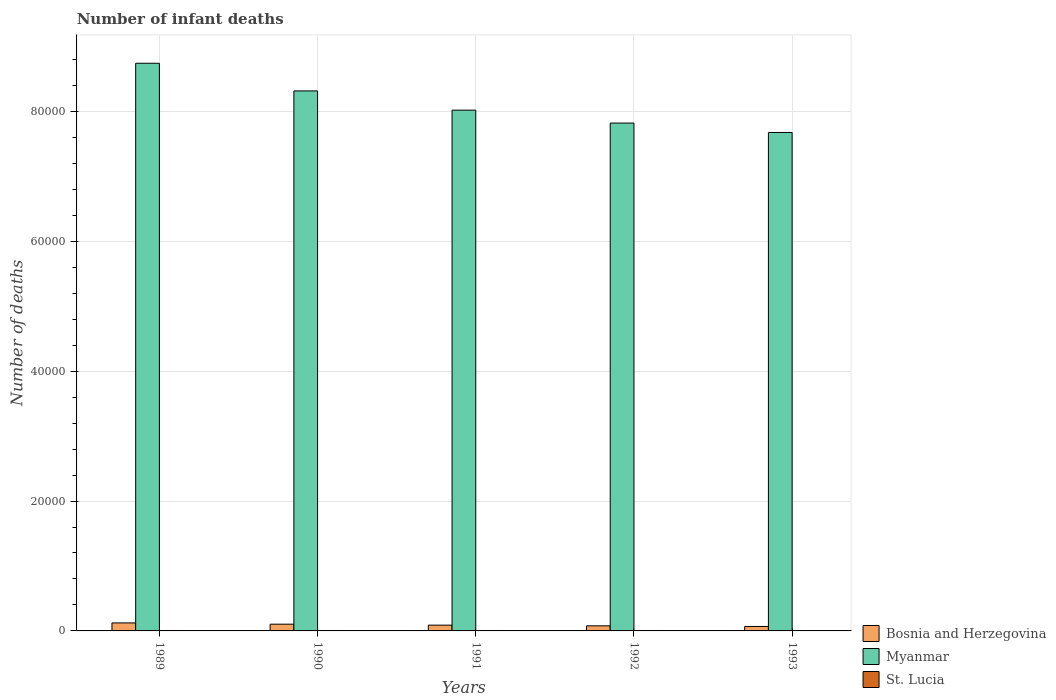How many groups of bars are there?
Offer a very short reply. 5. Are the number of bars per tick equal to the number of legend labels?
Make the answer very short. Yes. What is the label of the 5th group of bars from the left?
Provide a succinct answer. 1993. In how many cases, is the number of bars for a given year not equal to the number of legend labels?
Offer a very short reply. 0. What is the number of infant deaths in Myanmar in 1993?
Ensure brevity in your answer.  7.67e+04. Across all years, what is the maximum number of infant deaths in St. Lucia?
Provide a short and direct response. 67. Across all years, what is the minimum number of infant deaths in Bosnia and Herzegovina?
Offer a terse response. 687. In which year was the number of infant deaths in St. Lucia maximum?
Ensure brevity in your answer.  1989. What is the total number of infant deaths in Myanmar in the graph?
Make the answer very short. 4.06e+05. What is the difference between the number of infant deaths in Bosnia and Herzegovina in 1989 and that in 1993?
Your answer should be very brief. 547. What is the difference between the number of infant deaths in Myanmar in 1993 and the number of infant deaths in Bosnia and Herzegovina in 1990?
Keep it short and to the point. 7.57e+04. What is the average number of infant deaths in Myanmar per year?
Offer a very short reply. 8.11e+04. In the year 1993, what is the difference between the number of infant deaths in Bosnia and Herzegovina and number of infant deaths in Myanmar?
Your answer should be compact. -7.61e+04. What is the ratio of the number of infant deaths in Myanmar in 1989 to that in 1990?
Offer a very short reply. 1.05. Is the number of infant deaths in Myanmar in 1989 less than that in 1993?
Ensure brevity in your answer.  No. What is the difference between the highest and the lowest number of infant deaths in Bosnia and Herzegovina?
Make the answer very short. 547. In how many years, is the number of infant deaths in St. Lucia greater than the average number of infant deaths in St. Lucia taken over all years?
Provide a short and direct response. 3. What does the 3rd bar from the left in 1993 represents?
Your response must be concise. St. Lucia. What does the 3rd bar from the right in 1993 represents?
Provide a succinct answer. Bosnia and Herzegovina. Is it the case that in every year, the sum of the number of infant deaths in Myanmar and number of infant deaths in St. Lucia is greater than the number of infant deaths in Bosnia and Herzegovina?
Provide a succinct answer. Yes. Are all the bars in the graph horizontal?
Ensure brevity in your answer.  No. Are the values on the major ticks of Y-axis written in scientific E-notation?
Keep it short and to the point. No. Does the graph contain grids?
Your answer should be very brief. Yes. Where does the legend appear in the graph?
Provide a succinct answer. Bottom right. How are the legend labels stacked?
Provide a succinct answer. Vertical. What is the title of the graph?
Give a very brief answer. Number of infant deaths. What is the label or title of the X-axis?
Give a very brief answer. Years. What is the label or title of the Y-axis?
Offer a terse response. Number of deaths. What is the Number of deaths of Bosnia and Herzegovina in 1989?
Make the answer very short. 1234. What is the Number of deaths of Myanmar in 1989?
Offer a terse response. 8.74e+04. What is the Number of deaths in Bosnia and Herzegovina in 1990?
Provide a short and direct response. 1037. What is the Number of deaths in Myanmar in 1990?
Make the answer very short. 8.31e+04. What is the Number of deaths of Bosnia and Herzegovina in 1991?
Ensure brevity in your answer.  888. What is the Number of deaths in Myanmar in 1991?
Make the answer very short. 8.02e+04. What is the Number of deaths of St. Lucia in 1991?
Your answer should be very brief. 66. What is the Number of deaths of Bosnia and Herzegovina in 1992?
Your answer should be compact. 784. What is the Number of deaths in Myanmar in 1992?
Provide a short and direct response. 7.82e+04. What is the Number of deaths in Bosnia and Herzegovina in 1993?
Your response must be concise. 687. What is the Number of deaths of Myanmar in 1993?
Offer a terse response. 7.67e+04. Across all years, what is the maximum Number of deaths in Bosnia and Herzegovina?
Make the answer very short. 1234. Across all years, what is the maximum Number of deaths in Myanmar?
Offer a terse response. 8.74e+04. Across all years, what is the minimum Number of deaths of Bosnia and Herzegovina?
Make the answer very short. 687. Across all years, what is the minimum Number of deaths of Myanmar?
Provide a short and direct response. 7.67e+04. What is the total Number of deaths of Bosnia and Herzegovina in the graph?
Your answer should be compact. 4630. What is the total Number of deaths in Myanmar in the graph?
Provide a short and direct response. 4.06e+05. What is the total Number of deaths of St. Lucia in the graph?
Ensure brevity in your answer.  328. What is the difference between the Number of deaths of Bosnia and Herzegovina in 1989 and that in 1990?
Your answer should be compact. 197. What is the difference between the Number of deaths of Myanmar in 1989 and that in 1990?
Give a very brief answer. 4257. What is the difference between the Number of deaths of St. Lucia in 1989 and that in 1990?
Make the answer very short. 1. What is the difference between the Number of deaths in Bosnia and Herzegovina in 1989 and that in 1991?
Make the answer very short. 346. What is the difference between the Number of deaths of Myanmar in 1989 and that in 1991?
Make the answer very short. 7220. What is the difference between the Number of deaths in Bosnia and Herzegovina in 1989 and that in 1992?
Offer a terse response. 450. What is the difference between the Number of deaths of Myanmar in 1989 and that in 1992?
Give a very brief answer. 9208. What is the difference between the Number of deaths of Bosnia and Herzegovina in 1989 and that in 1993?
Make the answer very short. 547. What is the difference between the Number of deaths in Myanmar in 1989 and that in 1993?
Your answer should be very brief. 1.07e+04. What is the difference between the Number of deaths of Bosnia and Herzegovina in 1990 and that in 1991?
Offer a terse response. 149. What is the difference between the Number of deaths in Myanmar in 1990 and that in 1991?
Provide a short and direct response. 2963. What is the difference between the Number of deaths of Bosnia and Herzegovina in 1990 and that in 1992?
Your answer should be compact. 253. What is the difference between the Number of deaths in Myanmar in 1990 and that in 1992?
Your answer should be very brief. 4951. What is the difference between the Number of deaths in St. Lucia in 1990 and that in 1992?
Your answer should be very brief. 1. What is the difference between the Number of deaths of Bosnia and Herzegovina in 1990 and that in 1993?
Provide a short and direct response. 350. What is the difference between the Number of deaths in Myanmar in 1990 and that in 1993?
Ensure brevity in your answer.  6398. What is the difference between the Number of deaths in Bosnia and Herzegovina in 1991 and that in 1992?
Keep it short and to the point. 104. What is the difference between the Number of deaths in Myanmar in 1991 and that in 1992?
Your response must be concise. 1988. What is the difference between the Number of deaths in St. Lucia in 1991 and that in 1992?
Offer a terse response. 1. What is the difference between the Number of deaths of Bosnia and Herzegovina in 1991 and that in 1993?
Keep it short and to the point. 201. What is the difference between the Number of deaths in Myanmar in 1991 and that in 1993?
Your answer should be compact. 3435. What is the difference between the Number of deaths in St. Lucia in 1991 and that in 1993?
Offer a very short reply. 2. What is the difference between the Number of deaths in Bosnia and Herzegovina in 1992 and that in 1993?
Your answer should be compact. 97. What is the difference between the Number of deaths in Myanmar in 1992 and that in 1993?
Keep it short and to the point. 1447. What is the difference between the Number of deaths of Bosnia and Herzegovina in 1989 and the Number of deaths of Myanmar in 1990?
Offer a very short reply. -8.19e+04. What is the difference between the Number of deaths of Bosnia and Herzegovina in 1989 and the Number of deaths of St. Lucia in 1990?
Ensure brevity in your answer.  1168. What is the difference between the Number of deaths in Myanmar in 1989 and the Number of deaths in St. Lucia in 1990?
Your response must be concise. 8.73e+04. What is the difference between the Number of deaths in Bosnia and Herzegovina in 1989 and the Number of deaths in Myanmar in 1991?
Give a very brief answer. -7.89e+04. What is the difference between the Number of deaths in Bosnia and Herzegovina in 1989 and the Number of deaths in St. Lucia in 1991?
Offer a terse response. 1168. What is the difference between the Number of deaths in Myanmar in 1989 and the Number of deaths in St. Lucia in 1991?
Offer a terse response. 8.73e+04. What is the difference between the Number of deaths of Bosnia and Herzegovina in 1989 and the Number of deaths of Myanmar in 1992?
Offer a terse response. -7.70e+04. What is the difference between the Number of deaths in Bosnia and Herzegovina in 1989 and the Number of deaths in St. Lucia in 1992?
Your answer should be compact. 1169. What is the difference between the Number of deaths in Myanmar in 1989 and the Number of deaths in St. Lucia in 1992?
Provide a short and direct response. 8.73e+04. What is the difference between the Number of deaths of Bosnia and Herzegovina in 1989 and the Number of deaths of Myanmar in 1993?
Your answer should be very brief. -7.55e+04. What is the difference between the Number of deaths of Bosnia and Herzegovina in 1989 and the Number of deaths of St. Lucia in 1993?
Offer a very short reply. 1170. What is the difference between the Number of deaths in Myanmar in 1989 and the Number of deaths in St. Lucia in 1993?
Offer a very short reply. 8.73e+04. What is the difference between the Number of deaths in Bosnia and Herzegovina in 1990 and the Number of deaths in Myanmar in 1991?
Offer a very short reply. -7.91e+04. What is the difference between the Number of deaths in Bosnia and Herzegovina in 1990 and the Number of deaths in St. Lucia in 1991?
Give a very brief answer. 971. What is the difference between the Number of deaths in Myanmar in 1990 and the Number of deaths in St. Lucia in 1991?
Offer a terse response. 8.31e+04. What is the difference between the Number of deaths of Bosnia and Herzegovina in 1990 and the Number of deaths of Myanmar in 1992?
Offer a terse response. -7.72e+04. What is the difference between the Number of deaths of Bosnia and Herzegovina in 1990 and the Number of deaths of St. Lucia in 1992?
Give a very brief answer. 972. What is the difference between the Number of deaths of Myanmar in 1990 and the Number of deaths of St. Lucia in 1992?
Your answer should be compact. 8.31e+04. What is the difference between the Number of deaths of Bosnia and Herzegovina in 1990 and the Number of deaths of Myanmar in 1993?
Ensure brevity in your answer.  -7.57e+04. What is the difference between the Number of deaths of Bosnia and Herzegovina in 1990 and the Number of deaths of St. Lucia in 1993?
Keep it short and to the point. 973. What is the difference between the Number of deaths in Myanmar in 1990 and the Number of deaths in St. Lucia in 1993?
Keep it short and to the point. 8.31e+04. What is the difference between the Number of deaths of Bosnia and Herzegovina in 1991 and the Number of deaths of Myanmar in 1992?
Your answer should be very brief. -7.73e+04. What is the difference between the Number of deaths of Bosnia and Herzegovina in 1991 and the Number of deaths of St. Lucia in 1992?
Provide a short and direct response. 823. What is the difference between the Number of deaths of Myanmar in 1991 and the Number of deaths of St. Lucia in 1992?
Give a very brief answer. 8.01e+04. What is the difference between the Number of deaths of Bosnia and Herzegovina in 1991 and the Number of deaths of Myanmar in 1993?
Offer a terse response. -7.59e+04. What is the difference between the Number of deaths in Bosnia and Herzegovina in 1991 and the Number of deaths in St. Lucia in 1993?
Keep it short and to the point. 824. What is the difference between the Number of deaths of Myanmar in 1991 and the Number of deaths of St. Lucia in 1993?
Offer a very short reply. 8.01e+04. What is the difference between the Number of deaths of Bosnia and Herzegovina in 1992 and the Number of deaths of Myanmar in 1993?
Offer a terse response. -7.60e+04. What is the difference between the Number of deaths of Bosnia and Herzegovina in 1992 and the Number of deaths of St. Lucia in 1993?
Give a very brief answer. 720. What is the difference between the Number of deaths in Myanmar in 1992 and the Number of deaths in St. Lucia in 1993?
Make the answer very short. 7.81e+04. What is the average Number of deaths in Bosnia and Herzegovina per year?
Make the answer very short. 926. What is the average Number of deaths of Myanmar per year?
Ensure brevity in your answer.  8.11e+04. What is the average Number of deaths in St. Lucia per year?
Keep it short and to the point. 65.6. In the year 1989, what is the difference between the Number of deaths of Bosnia and Herzegovina and Number of deaths of Myanmar?
Make the answer very short. -8.62e+04. In the year 1989, what is the difference between the Number of deaths in Bosnia and Herzegovina and Number of deaths in St. Lucia?
Provide a succinct answer. 1167. In the year 1989, what is the difference between the Number of deaths of Myanmar and Number of deaths of St. Lucia?
Ensure brevity in your answer.  8.73e+04. In the year 1990, what is the difference between the Number of deaths in Bosnia and Herzegovina and Number of deaths in Myanmar?
Make the answer very short. -8.21e+04. In the year 1990, what is the difference between the Number of deaths of Bosnia and Herzegovina and Number of deaths of St. Lucia?
Give a very brief answer. 971. In the year 1990, what is the difference between the Number of deaths of Myanmar and Number of deaths of St. Lucia?
Offer a very short reply. 8.31e+04. In the year 1991, what is the difference between the Number of deaths in Bosnia and Herzegovina and Number of deaths in Myanmar?
Offer a terse response. -7.93e+04. In the year 1991, what is the difference between the Number of deaths of Bosnia and Herzegovina and Number of deaths of St. Lucia?
Offer a terse response. 822. In the year 1991, what is the difference between the Number of deaths of Myanmar and Number of deaths of St. Lucia?
Offer a very short reply. 8.01e+04. In the year 1992, what is the difference between the Number of deaths of Bosnia and Herzegovina and Number of deaths of Myanmar?
Provide a succinct answer. -7.74e+04. In the year 1992, what is the difference between the Number of deaths of Bosnia and Herzegovina and Number of deaths of St. Lucia?
Your answer should be compact. 719. In the year 1992, what is the difference between the Number of deaths of Myanmar and Number of deaths of St. Lucia?
Provide a short and direct response. 7.81e+04. In the year 1993, what is the difference between the Number of deaths of Bosnia and Herzegovina and Number of deaths of Myanmar?
Keep it short and to the point. -7.61e+04. In the year 1993, what is the difference between the Number of deaths in Bosnia and Herzegovina and Number of deaths in St. Lucia?
Make the answer very short. 623. In the year 1993, what is the difference between the Number of deaths in Myanmar and Number of deaths in St. Lucia?
Offer a very short reply. 7.67e+04. What is the ratio of the Number of deaths of Bosnia and Herzegovina in 1989 to that in 1990?
Provide a succinct answer. 1.19. What is the ratio of the Number of deaths of Myanmar in 1989 to that in 1990?
Your response must be concise. 1.05. What is the ratio of the Number of deaths of St. Lucia in 1989 to that in 1990?
Offer a terse response. 1.02. What is the ratio of the Number of deaths of Bosnia and Herzegovina in 1989 to that in 1991?
Keep it short and to the point. 1.39. What is the ratio of the Number of deaths of Myanmar in 1989 to that in 1991?
Offer a very short reply. 1.09. What is the ratio of the Number of deaths of St. Lucia in 1989 to that in 1991?
Make the answer very short. 1.02. What is the ratio of the Number of deaths of Bosnia and Herzegovina in 1989 to that in 1992?
Your response must be concise. 1.57. What is the ratio of the Number of deaths of Myanmar in 1989 to that in 1992?
Your response must be concise. 1.12. What is the ratio of the Number of deaths in St. Lucia in 1989 to that in 1992?
Your answer should be compact. 1.03. What is the ratio of the Number of deaths of Bosnia and Herzegovina in 1989 to that in 1993?
Your response must be concise. 1.8. What is the ratio of the Number of deaths of Myanmar in 1989 to that in 1993?
Provide a short and direct response. 1.14. What is the ratio of the Number of deaths of St. Lucia in 1989 to that in 1993?
Provide a succinct answer. 1.05. What is the ratio of the Number of deaths in Bosnia and Herzegovina in 1990 to that in 1991?
Ensure brevity in your answer.  1.17. What is the ratio of the Number of deaths of Bosnia and Herzegovina in 1990 to that in 1992?
Provide a succinct answer. 1.32. What is the ratio of the Number of deaths of Myanmar in 1990 to that in 1992?
Your answer should be compact. 1.06. What is the ratio of the Number of deaths of St. Lucia in 1990 to that in 1992?
Provide a succinct answer. 1.02. What is the ratio of the Number of deaths in Bosnia and Herzegovina in 1990 to that in 1993?
Ensure brevity in your answer.  1.51. What is the ratio of the Number of deaths of Myanmar in 1990 to that in 1993?
Make the answer very short. 1.08. What is the ratio of the Number of deaths in St. Lucia in 1990 to that in 1993?
Your response must be concise. 1.03. What is the ratio of the Number of deaths in Bosnia and Herzegovina in 1991 to that in 1992?
Your answer should be compact. 1.13. What is the ratio of the Number of deaths of Myanmar in 1991 to that in 1992?
Your response must be concise. 1.03. What is the ratio of the Number of deaths of St. Lucia in 1991 to that in 1992?
Your answer should be very brief. 1.02. What is the ratio of the Number of deaths of Bosnia and Herzegovina in 1991 to that in 1993?
Provide a succinct answer. 1.29. What is the ratio of the Number of deaths in Myanmar in 1991 to that in 1993?
Provide a short and direct response. 1.04. What is the ratio of the Number of deaths in St. Lucia in 1991 to that in 1993?
Provide a succinct answer. 1.03. What is the ratio of the Number of deaths of Bosnia and Herzegovina in 1992 to that in 1993?
Provide a short and direct response. 1.14. What is the ratio of the Number of deaths of Myanmar in 1992 to that in 1993?
Keep it short and to the point. 1.02. What is the ratio of the Number of deaths in St. Lucia in 1992 to that in 1993?
Offer a terse response. 1.02. What is the difference between the highest and the second highest Number of deaths in Bosnia and Herzegovina?
Offer a very short reply. 197. What is the difference between the highest and the second highest Number of deaths of Myanmar?
Ensure brevity in your answer.  4257. What is the difference between the highest and the lowest Number of deaths of Bosnia and Herzegovina?
Provide a short and direct response. 547. What is the difference between the highest and the lowest Number of deaths of Myanmar?
Keep it short and to the point. 1.07e+04. 